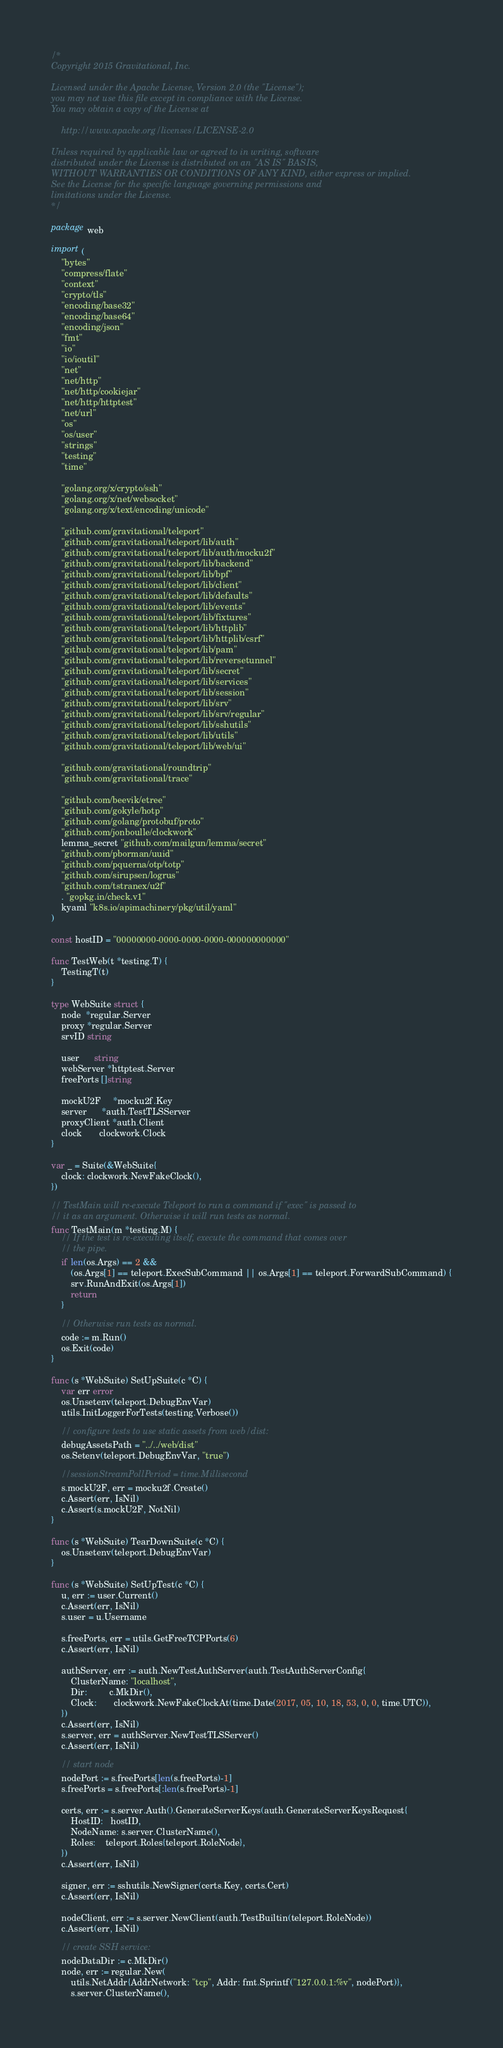Convert code to text. <code><loc_0><loc_0><loc_500><loc_500><_Go_>/*
Copyright 2015 Gravitational, Inc.

Licensed under the Apache License, Version 2.0 (the "License");
you may not use this file except in compliance with the License.
You may obtain a copy of the License at

    http://www.apache.org/licenses/LICENSE-2.0

Unless required by applicable law or agreed to in writing, software
distributed under the License is distributed on an "AS IS" BASIS,
WITHOUT WARRANTIES OR CONDITIONS OF ANY KIND, either express or implied.
See the License for the specific language governing permissions and
limitations under the License.
*/

package web

import (
	"bytes"
	"compress/flate"
	"context"
	"crypto/tls"
	"encoding/base32"
	"encoding/base64"
	"encoding/json"
	"fmt"
	"io"
	"io/ioutil"
	"net"
	"net/http"
	"net/http/cookiejar"
	"net/http/httptest"
	"net/url"
	"os"
	"os/user"
	"strings"
	"testing"
	"time"

	"golang.org/x/crypto/ssh"
	"golang.org/x/net/websocket"
	"golang.org/x/text/encoding/unicode"

	"github.com/gravitational/teleport"
	"github.com/gravitational/teleport/lib/auth"
	"github.com/gravitational/teleport/lib/auth/mocku2f"
	"github.com/gravitational/teleport/lib/backend"
	"github.com/gravitational/teleport/lib/bpf"
	"github.com/gravitational/teleport/lib/client"
	"github.com/gravitational/teleport/lib/defaults"
	"github.com/gravitational/teleport/lib/events"
	"github.com/gravitational/teleport/lib/fixtures"
	"github.com/gravitational/teleport/lib/httplib"
	"github.com/gravitational/teleport/lib/httplib/csrf"
	"github.com/gravitational/teleport/lib/pam"
	"github.com/gravitational/teleport/lib/reversetunnel"
	"github.com/gravitational/teleport/lib/secret"
	"github.com/gravitational/teleport/lib/services"
	"github.com/gravitational/teleport/lib/session"
	"github.com/gravitational/teleport/lib/srv"
	"github.com/gravitational/teleport/lib/srv/regular"
	"github.com/gravitational/teleport/lib/sshutils"
	"github.com/gravitational/teleport/lib/utils"
	"github.com/gravitational/teleport/lib/web/ui"

	"github.com/gravitational/roundtrip"
	"github.com/gravitational/trace"

	"github.com/beevik/etree"
	"github.com/gokyle/hotp"
	"github.com/golang/protobuf/proto"
	"github.com/jonboulle/clockwork"
	lemma_secret "github.com/mailgun/lemma/secret"
	"github.com/pborman/uuid"
	"github.com/pquerna/otp/totp"
	"github.com/sirupsen/logrus"
	"github.com/tstranex/u2f"
	. "gopkg.in/check.v1"
	kyaml "k8s.io/apimachinery/pkg/util/yaml"
)

const hostID = "00000000-0000-0000-0000-000000000000"

func TestWeb(t *testing.T) {
	TestingT(t)
}

type WebSuite struct {
	node  *regular.Server
	proxy *regular.Server
	srvID string

	user      string
	webServer *httptest.Server
	freePorts []string

	mockU2F     *mocku2f.Key
	server      *auth.TestTLSServer
	proxyClient *auth.Client
	clock       clockwork.Clock
}

var _ = Suite(&WebSuite{
	clock: clockwork.NewFakeClock(),
})

// TestMain will re-execute Teleport to run a command if "exec" is passed to
// it as an argument. Otherwise it will run tests as normal.
func TestMain(m *testing.M) {
	// If the test is re-executing itself, execute the command that comes over
	// the pipe.
	if len(os.Args) == 2 &&
		(os.Args[1] == teleport.ExecSubCommand || os.Args[1] == teleport.ForwardSubCommand) {
		srv.RunAndExit(os.Args[1])
		return
	}

	// Otherwise run tests as normal.
	code := m.Run()
	os.Exit(code)
}

func (s *WebSuite) SetUpSuite(c *C) {
	var err error
	os.Unsetenv(teleport.DebugEnvVar)
	utils.InitLoggerForTests(testing.Verbose())

	// configure tests to use static assets from web/dist:
	debugAssetsPath = "../../web/dist"
	os.Setenv(teleport.DebugEnvVar, "true")

	//sessionStreamPollPeriod = time.Millisecond
	s.mockU2F, err = mocku2f.Create()
	c.Assert(err, IsNil)
	c.Assert(s.mockU2F, NotNil)
}

func (s *WebSuite) TearDownSuite(c *C) {
	os.Unsetenv(teleport.DebugEnvVar)
}

func (s *WebSuite) SetUpTest(c *C) {
	u, err := user.Current()
	c.Assert(err, IsNil)
	s.user = u.Username

	s.freePorts, err = utils.GetFreeTCPPorts(6)
	c.Assert(err, IsNil)

	authServer, err := auth.NewTestAuthServer(auth.TestAuthServerConfig{
		ClusterName: "localhost",
		Dir:         c.MkDir(),
		Clock:       clockwork.NewFakeClockAt(time.Date(2017, 05, 10, 18, 53, 0, 0, time.UTC)),
	})
	c.Assert(err, IsNil)
	s.server, err = authServer.NewTestTLSServer()
	c.Assert(err, IsNil)

	// start node
	nodePort := s.freePorts[len(s.freePorts)-1]
	s.freePorts = s.freePorts[:len(s.freePorts)-1]

	certs, err := s.server.Auth().GenerateServerKeys(auth.GenerateServerKeysRequest{
		HostID:   hostID,
		NodeName: s.server.ClusterName(),
		Roles:    teleport.Roles{teleport.RoleNode},
	})
	c.Assert(err, IsNil)

	signer, err := sshutils.NewSigner(certs.Key, certs.Cert)
	c.Assert(err, IsNil)

	nodeClient, err := s.server.NewClient(auth.TestBuiltin(teleport.RoleNode))
	c.Assert(err, IsNil)

	// create SSH service:
	nodeDataDir := c.MkDir()
	node, err := regular.New(
		utils.NetAddr{AddrNetwork: "tcp", Addr: fmt.Sprintf("127.0.0.1:%v", nodePort)},
		s.server.ClusterName(),</code> 